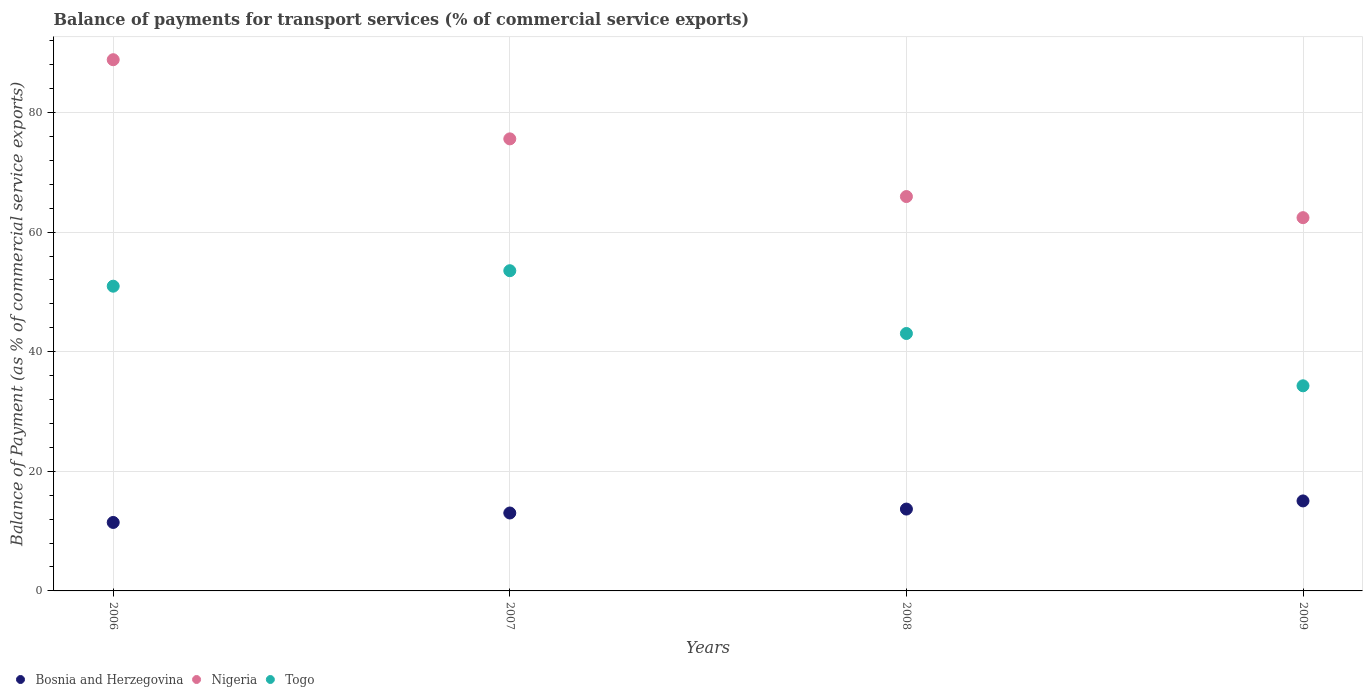How many different coloured dotlines are there?
Offer a terse response. 3. What is the balance of payments for transport services in Togo in 2009?
Provide a short and direct response. 34.3. Across all years, what is the maximum balance of payments for transport services in Togo?
Give a very brief answer. 53.54. Across all years, what is the minimum balance of payments for transport services in Bosnia and Herzegovina?
Give a very brief answer. 11.45. In which year was the balance of payments for transport services in Nigeria maximum?
Your answer should be compact. 2006. In which year was the balance of payments for transport services in Bosnia and Herzegovina minimum?
Give a very brief answer. 2006. What is the total balance of payments for transport services in Togo in the graph?
Give a very brief answer. 181.84. What is the difference between the balance of payments for transport services in Nigeria in 2006 and that in 2009?
Provide a short and direct response. 26.41. What is the difference between the balance of payments for transport services in Nigeria in 2006 and the balance of payments for transport services in Togo in 2009?
Provide a succinct answer. 54.53. What is the average balance of payments for transport services in Togo per year?
Keep it short and to the point. 45.46. In the year 2009, what is the difference between the balance of payments for transport services in Togo and balance of payments for transport services in Nigeria?
Offer a terse response. -28.11. In how many years, is the balance of payments for transport services in Togo greater than 84 %?
Keep it short and to the point. 0. What is the ratio of the balance of payments for transport services in Bosnia and Herzegovina in 2007 to that in 2008?
Keep it short and to the point. 0.95. Is the difference between the balance of payments for transport services in Togo in 2006 and 2009 greater than the difference between the balance of payments for transport services in Nigeria in 2006 and 2009?
Provide a short and direct response. No. What is the difference between the highest and the second highest balance of payments for transport services in Nigeria?
Offer a terse response. 13.24. What is the difference between the highest and the lowest balance of payments for transport services in Nigeria?
Offer a terse response. 26.41. In how many years, is the balance of payments for transport services in Nigeria greater than the average balance of payments for transport services in Nigeria taken over all years?
Provide a short and direct response. 2. Is the sum of the balance of payments for transport services in Nigeria in 2007 and 2009 greater than the maximum balance of payments for transport services in Togo across all years?
Ensure brevity in your answer.  Yes. Is it the case that in every year, the sum of the balance of payments for transport services in Bosnia and Herzegovina and balance of payments for transport services in Togo  is greater than the balance of payments for transport services in Nigeria?
Give a very brief answer. No. Is the balance of payments for transport services in Togo strictly less than the balance of payments for transport services in Nigeria over the years?
Offer a very short reply. Yes. Are the values on the major ticks of Y-axis written in scientific E-notation?
Offer a terse response. No. Does the graph contain any zero values?
Your answer should be compact. No. Does the graph contain grids?
Keep it short and to the point. Yes. Where does the legend appear in the graph?
Your answer should be compact. Bottom left. What is the title of the graph?
Your response must be concise. Balance of payments for transport services (% of commercial service exports). What is the label or title of the Y-axis?
Offer a terse response. Balance of Payment (as % of commercial service exports). What is the Balance of Payment (as % of commercial service exports) in Bosnia and Herzegovina in 2006?
Provide a succinct answer. 11.45. What is the Balance of Payment (as % of commercial service exports) in Nigeria in 2006?
Offer a very short reply. 88.82. What is the Balance of Payment (as % of commercial service exports) in Togo in 2006?
Provide a succinct answer. 50.95. What is the Balance of Payment (as % of commercial service exports) of Bosnia and Herzegovina in 2007?
Provide a succinct answer. 13.03. What is the Balance of Payment (as % of commercial service exports) of Nigeria in 2007?
Ensure brevity in your answer.  75.59. What is the Balance of Payment (as % of commercial service exports) of Togo in 2007?
Your answer should be very brief. 53.54. What is the Balance of Payment (as % of commercial service exports) in Bosnia and Herzegovina in 2008?
Provide a short and direct response. 13.69. What is the Balance of Payment (as % of commercial service exports) of Nigeria in 2008?
Give a very brief answer. 65.94. What is the Balance of Payment (as % of commercial service exports) in Togo in 2008?
Keep it short and to the point. 43.04. What is the Balance of Payment (as % of commercial service exports) of Bosnia and Herzegovina in 2009?
Keep it short and to the point. 15.05. What is the Balance of Payment (as % of commercial service exports) in Nigeria in 2009?
Ensure brevity in your answer.  62.41. What is the Balance of Payment (as % of commercial service exports) in Togo in 2009?
Offer a terse response. 34.3. Across all years, what is the maximum Balance of Payment (as % of commercial service exports) in Bosnia and Herzegovina?
Offer a terse response. 15.05. Across all years, what is the maximum Balance of Payment (as % of commercial service exports) in Nigeria?
Your response must be concise. 88.82. Across all years, what is the maximum Balance of Payment (as % of commercial service exports) in Togo?
Your answer should be compact. 53.54. Across all years, what is the minimum Balance of Payment (as % of commercial service exports) in Bosnia and Herzegovina?
Give a very brief answer. 11.45. Across all years, what is the minimum Balance of Payment (as % of commercial service exports) in Nigeria?
Ensure brevity in your answer.  62.41. Across all years, what is the minimum Balance of Payment (as % of commercial service exports) in Togo?
Give a very brief answer. 34.3. What is the total Balance of Payment (as % of commercial service exports) of Bosnia and Herzegovina in the graph?
Your answer should be compact. 53.21. What is the total Balance of Payment (as % of commercial service exports) of Nigeria in the graph?
Make the answer very short. 292.77. What is the total Balance of Payment (as % of commercial service exports) in Togo in the graph?
Ensure brevity in your answer.  181.84. What is the difference between the Balance of Payment (as % of commercial service exports) in Bosnia and Herzegovina in 2006 and that in 2007?
Your answer should be very brief. -1.58. What is the difference between the Balance of Payment (as % of commercial service exports) of Nigeria in 2006 and that in 2007?
Make the answer very short. 13.24. What is the difference between the Balance of Payment (as % of commercial service exports) of Togo in 2006 and that in 2007?
Your answer should be compact. -2.59. What is the difference between the Balance of Payment (as % of commercial service exports) in Bosnia and Herzegovina in 2006 and that in 2008?
Give a very brief answer. -2.24. What is the difference between the Balance of Payment (as % of commercial service exports) in Nigeria in 2006 and that in 2008?
Provide a succinct answer. 22.88. What is the difference between the Balance of Payment (as % of commercial service exports) in Togo in 2006 and that in 2008?
Provide a succinct answer. 7.91. What is the difference between the Balance of Payment (as % of commercial service exports) of Bosnia and Herzegovina in 2006 and that in 2009?
Your answer should be compact. -3.6. What is the difference between the Balance of Payment (as % of commercial service exports) in Nigeria in 2006 and that in 2009?
Your answer should be compact. 26.41. What is the difference between the Balance of Payment (as % of commercial service exports) in Togo in 2006 and that in 2009?
Your answer should be very brief. 16.66. What is the difference between the Balance of Payment (as % of commercial service exports) in Bosnia and Herzegovina in 2007 and that in 2008?
Give a very brief answer. -0.66. What is the difference between the Balance of Payment (as % of commercial service exports) of Nigeria in 2007 and that in 2008?
Offer a very short reply. 9.64. What is the difference between the Balance of Payment (as % of commercial service exports) of Togo in 2007 and that in 2008?
Make the answer very short. 10.5. What is the difference between the Balance of Payment (as % of commercial service exports) of Bosnia and Herzegovina in 2007 and that in 2009?
Give a very brief answer. -2.02. What is the difference between the Balance of Payment (as % of commercial service exports) in Nigeria in 2007 and that in 2009?
Provide a succinct answer. 13.18. What is the difference between the Balance of Payment (as % of commercial service exports) in Togo in 2007 and that in 2009?
Ensure brevity in your answer.  19.25. What is the difference between the Balance of Payment (as % of commercial service exports) of Bosnia and Herzegovina in 2008 and that in 2009?
Offer a terse response. -1.36. What is the difference between the Balance of Payment (as % of commercial service exports) of Nigeria in 2008 and that in 2009?
Provide a short and direct response. 3.53. What is the difference between the Balance of Payment (as % of commercial service exports) of Togo in 2008 and that in 2009?
Make the answer very short. 8.75. What is the difference between the Balance of Payment (as % of commercial service exports) in Bosnia and Herzegovina in 2006 and the Balance of Payment (as % of commercial service exports) in Nigeria in 2007?
Your answer should be very brief. -64.14. What is the difference between the Balance of Payment (as % of commercial service exports) of Bosnia and Herzegovina in 2006 and the Balance of Payment (as % of commercial service exports) of Togo in 2007?
Keep it short and to the point. -42.09. What is the difference between the Balance of Payment (as % of commercial service exports) in Nigeria in 2006 and the Balance of Payment (as % of commercial service exports) in Togo in 2007?
Ensure brevity in your answer.  35.28. What is the difference between the Balance of Payment (as % of commercial service exports) in Bosnia and Herzegovina in 2006 and the Balance of Payment (as % of commercial service exports) in Nigeria in 2008?
Make the answer very short. -54.49. What is the difference between the Balance of Payment (as % of commercial service exports) of Bosnia and Herzegovina in 2006 and the Balance of Payment (as % of commercial service exports) of Togo in 2008?
Make the answer very short. -31.6. What is the difference between the Balance of Payment (as % of commercial service exports) in Nigeria in 2006 and the Balance of Payment (as % of commercial service exports) in Togo in 2008?
Your answer should be very brief. 45.78. What is the difference between the Balance of Payment (as % of commercial service exports) in Bosnia and Herzegovina in 2006 and the Balance of Payment (as % of commercial service exports) in Nigeria in 2009?
Provide a succinct answer. -50.96. What is the difference between the Balance of Payment (as % of commercial service exports) of Bosnia and Herzegovina in 2006 and the Balance of Payment (as % of commercial service exports) of Togo in 2009?
Offer a terse response. -22.85. What is the difference between the Balance of Payment (as % of commercial service exports) of Nigeria in 2006 and the Balance of Payment (as % of commercial service exports) of Togo in 2009?
Keep it short and to the point. 54.53. What is the difference between the Balance of Payment (as % of commercial service exports) of Bosnia and Herzegovina in 2007 and the Balance of Payment (as % of commercial service exports) of Nigeria in 2008?
Provide a short and direct response. -52.91. What is the difference between the Balance of Payment (as % of commercial service exports) of Bosnia and Herzegovina in 2007 and the Balance of Payment (as % of commercial service exports) of Togo in 2008?
Your answer should be compact. -30.02. What is the difference between the Balance of Payment (as % of commercial service exports) of Nigeria in 2007 and the Balance of Payment (as % of commercial service exports) of Togo in 2008?
Your answer should be very brief. 32.54. What is the difference between the Balance of Payment (as % of commercial service exports) in Bosnia and Herzegovina in 2007 and the Balance of Payment (as % of commercial service exports) in Nigeria in 2009?
Keep it short and to the point. -49.38. What is the difference between the Balance of Payment (as % of commercial service exports) of Bosnia and Herzegovina in 2007 and the Balance of Payment (as % of commercial service exports) of Togo in 2009?
Your answer should be very brief. -21.27. What is the difference between the Balance of Payment (as % of commercial service exports) in Nigeria in 2007 and the Balance of Payment (as % of commercial service exports) in Togo in 2009?
Provide a short and direct response. 41.29. What is the difference between the Balance of Payment (as % of commercial service exports) in Bosnia and Herzegovina in 2008 and the Balance of Payment (as % of commercial service exports) in Nigeria in 2009?
Your answer should be compact. -48.73. What is the difference between the Balance of Payment (as % of commercial service exports) of Bosnia and Herzegovina in 2008 and the Balance of Payment (as % of commercial service exports) of Togo in 2009?
Give a very brief answer. -20.61. What is the difference between the Balance of Payment (as % of commercial service exports) of Nigeria in 2008 and the Balance of Payment (as % of commercial service exports) of Togo in 2009?
Keep it short and to the point. 31.65. What is the average Balance of Payment (as % of commercial service exports) of Bosnia and Herzegovina per year?
Offer a terse response. 13.3. What is the average Balance of Payment (as % of commercial service exports) in Nigeria per year?
Give a very brief answer. 73.19. What is the average Balance of Payment (as % of commercial service exports) in Togo per year?
Give a very brief answer. 45.46. In the year 2006, what is the difference between the Balance of Payment (as % of commercial service exports) in Bosnia and Herzegovina and Balance of Payment (as % of commercial service exports) in Nigeria?
Make the answer very short. -77.37. In the year 2006, what is the difference between the Balance of Payment (as % of commercial service exports) of Bosnia and Herzegovina and Balance of Payment (as % of commercial service exports) of Togo?
Give a very brief answer. -39.5. In the year 2006, what is the difference between the Balance of Payment (as % of commercial service exports) in Nigeria and Balance of Payment (as % of commercial service exports) in Togo?
Make the answer very short. 37.87. In the year 2007, what is the difference between the Balance of Payment (as % of commercial service exports) of Bosnia and Herzegovina and Balance of Payment (as % of commercial service exports) of Nigeria?
Provide a short and direct response. -62.56. In the year 2007, what is the difference between the Balance of Payment (as % of commercial service exports) in Bosnia and Herzegovina and Balance of Payment (as % of commercial service exports) in Togo?
Make the answer very short. -40.51. In the year 2007, what is the difference between the Balance of Payment (as % of commercial service exports) of Nigeria and Balance of Payment (as % of commercial service exports) of Togo?
Give a very brief answer. 22.05. In the year 2008, what is the difference between the Balance of Payment (as % of commercial service exports) of Bosnia and Herzegovina and Balance of Payment (as % of commercial service exports) of Nigeria?
Provide a short and direct response. -52.26. In the year 2008, what is the difference between the Balance of Payment (as % of commercial service exports) of Bosnia and Herzegovina and Balance of Payment (as % of commercial service exports) of Togo?
Your answer should be very brief. -29.36. In the year 2008, what is the difference between the Balance of Payment (as % of commercial service exports) of Nigeria and Balance of Payment (as % of commercial service exports) of Togo?
Provide a short and direct response. 22.9. In the year 2009, what is the difference between the Balance of Payment (as % of commercial service exports) in Bosnia and Herzegovina and Balance of Payment (as % of commercial service exports) in Nigeria?
Make the answer very short. -47.36. In the year 2009, what is the difference between the Balance of Payment (as % of commercial service exports) of Bosnia and Herzegovina and Balance of Payment (as % of commercial service exports) of Togo?
Make the answer very short. -19.25. In the year 2009, what is the difference between the Balance of Payment (as % of commercial service exports) in Nigeria and Balance of Payment (as % of commercial service exports) in Togo?
Ensure brevity in your answer.  28.11. What is the ratio of the Balance of Payment (as % of commercial service exports) of Bosnia and Herzegovina in 2006 to that in 2007?
Your answer should be compact. 0.88. What is the ratio of the Balance of Payment (as % of commercial service exports) in Nigeria in 2006 to that in 2007?
Make the answer very short. 1.18. What is the ratio of the Balance of Payment (as % of commercial service exports) in Togo in 2006 to that in 2007?
Your response must be concise. 0.95. What is the ratio of the Balance of Payment (as % of commercial service exports) of Bosnia and Herzegovina in 2006 to that in 2008?
Make the answer very short. 0.84. What is the ratio of the Balance of Payment (as % of commercial service exports) of Nigeria in 2006 to that in 2008?
Keep it short and to the point. 1.35. What is the ratio of the Balance of Payment (as % of commercial service exports) in Togo in 2006 to that in 2008?
Ensure brevity in your answer.  1.18. What is the ratio of the Balance of Payment (as % of commercial service exports) in Bosnia and Herzegovina in 2006 to that in 2009?
Provide a short and direct response. 0.76. What is the ratio of the Balance of Payment (as % of commercial service exports) of Nigeria in 2006 to that in 2009?
Give a very brief answer. 1.42. What is the ratio of the Balance of Payment (as % of commercial service exports) of Togo in 2006 to that in 2009?
Ensure brevity in your answer.  1.49. What is the ratio of the Balance of Payment (as % of commercial service exports) in Nigeria in 2007 to that in 2008?
Keep it short and to the point. 1.15. What is the ratio of the Balance of Payment (as % of commercial service exports) in Togo in 2007 to that in 2008?
Give a very brief answer. 1.24. What is the ratio of the Balance of Payment (as % of commercial service exports) of Bosnia and Herzegovina in 2007 to that in 2009?
Ensure brevity in your answer.  0.87. What is the ratio of the Balance of Payment (as % of commercial service exports) of Nigeria in 2007 to that in 2009?
Your answer should be compact. 1.21. What is the ratio of the Balance of Payment (as % of commercial service exports) in Togo in 2007 to that in 2009?
Your answer should be very brief. 1.56. What is the ratio of the Balance of Payment (as % of commercial service exports) of Bosnia and Herzegovina in 2008 to that in 2009?
Your response must be concise. 0.91. What is the ratio of the Balance of Payment (as % of commercial service exports) in Nigeria in 2008 to that in 2009?
Offer a terse response. 1.06. What is the ratio of the Balance of Payment (as % of commercial service exports) in Togo in 2008 to that in 2009?
Offer a very short reply. 1.25. What is the difference between the highest and the second highest Balance of Payment (as % of commercial service exports) of Bosnia and Herzegovina?
Offer a terse response. 1.36. What is the difference between the highest and the second highest Balance of Payment (as % of commercial service exports) of Nigeria?
Make the answer very short. 13.24. What is the difference between the highest and the second highest Balance of Payment (as % of commercial service exports) in Togo?
Your response must be concise. 2.59. What is the difference between the highest and the lowest Balance of Payment (as % of commercial service exports) of Bosnia and Herzegovina?
Keep it short and to the point. 3.6. What is the difference between the highest and the lowest Balance of Payment (as % of commercial service exports) of Nigeria?
Offer a very short reply. 26.41. What is the difference between the highest and the lowest Balance of Payment (as % of commercial service exports) of Togo?
Offer a very short reply. 19.25. 